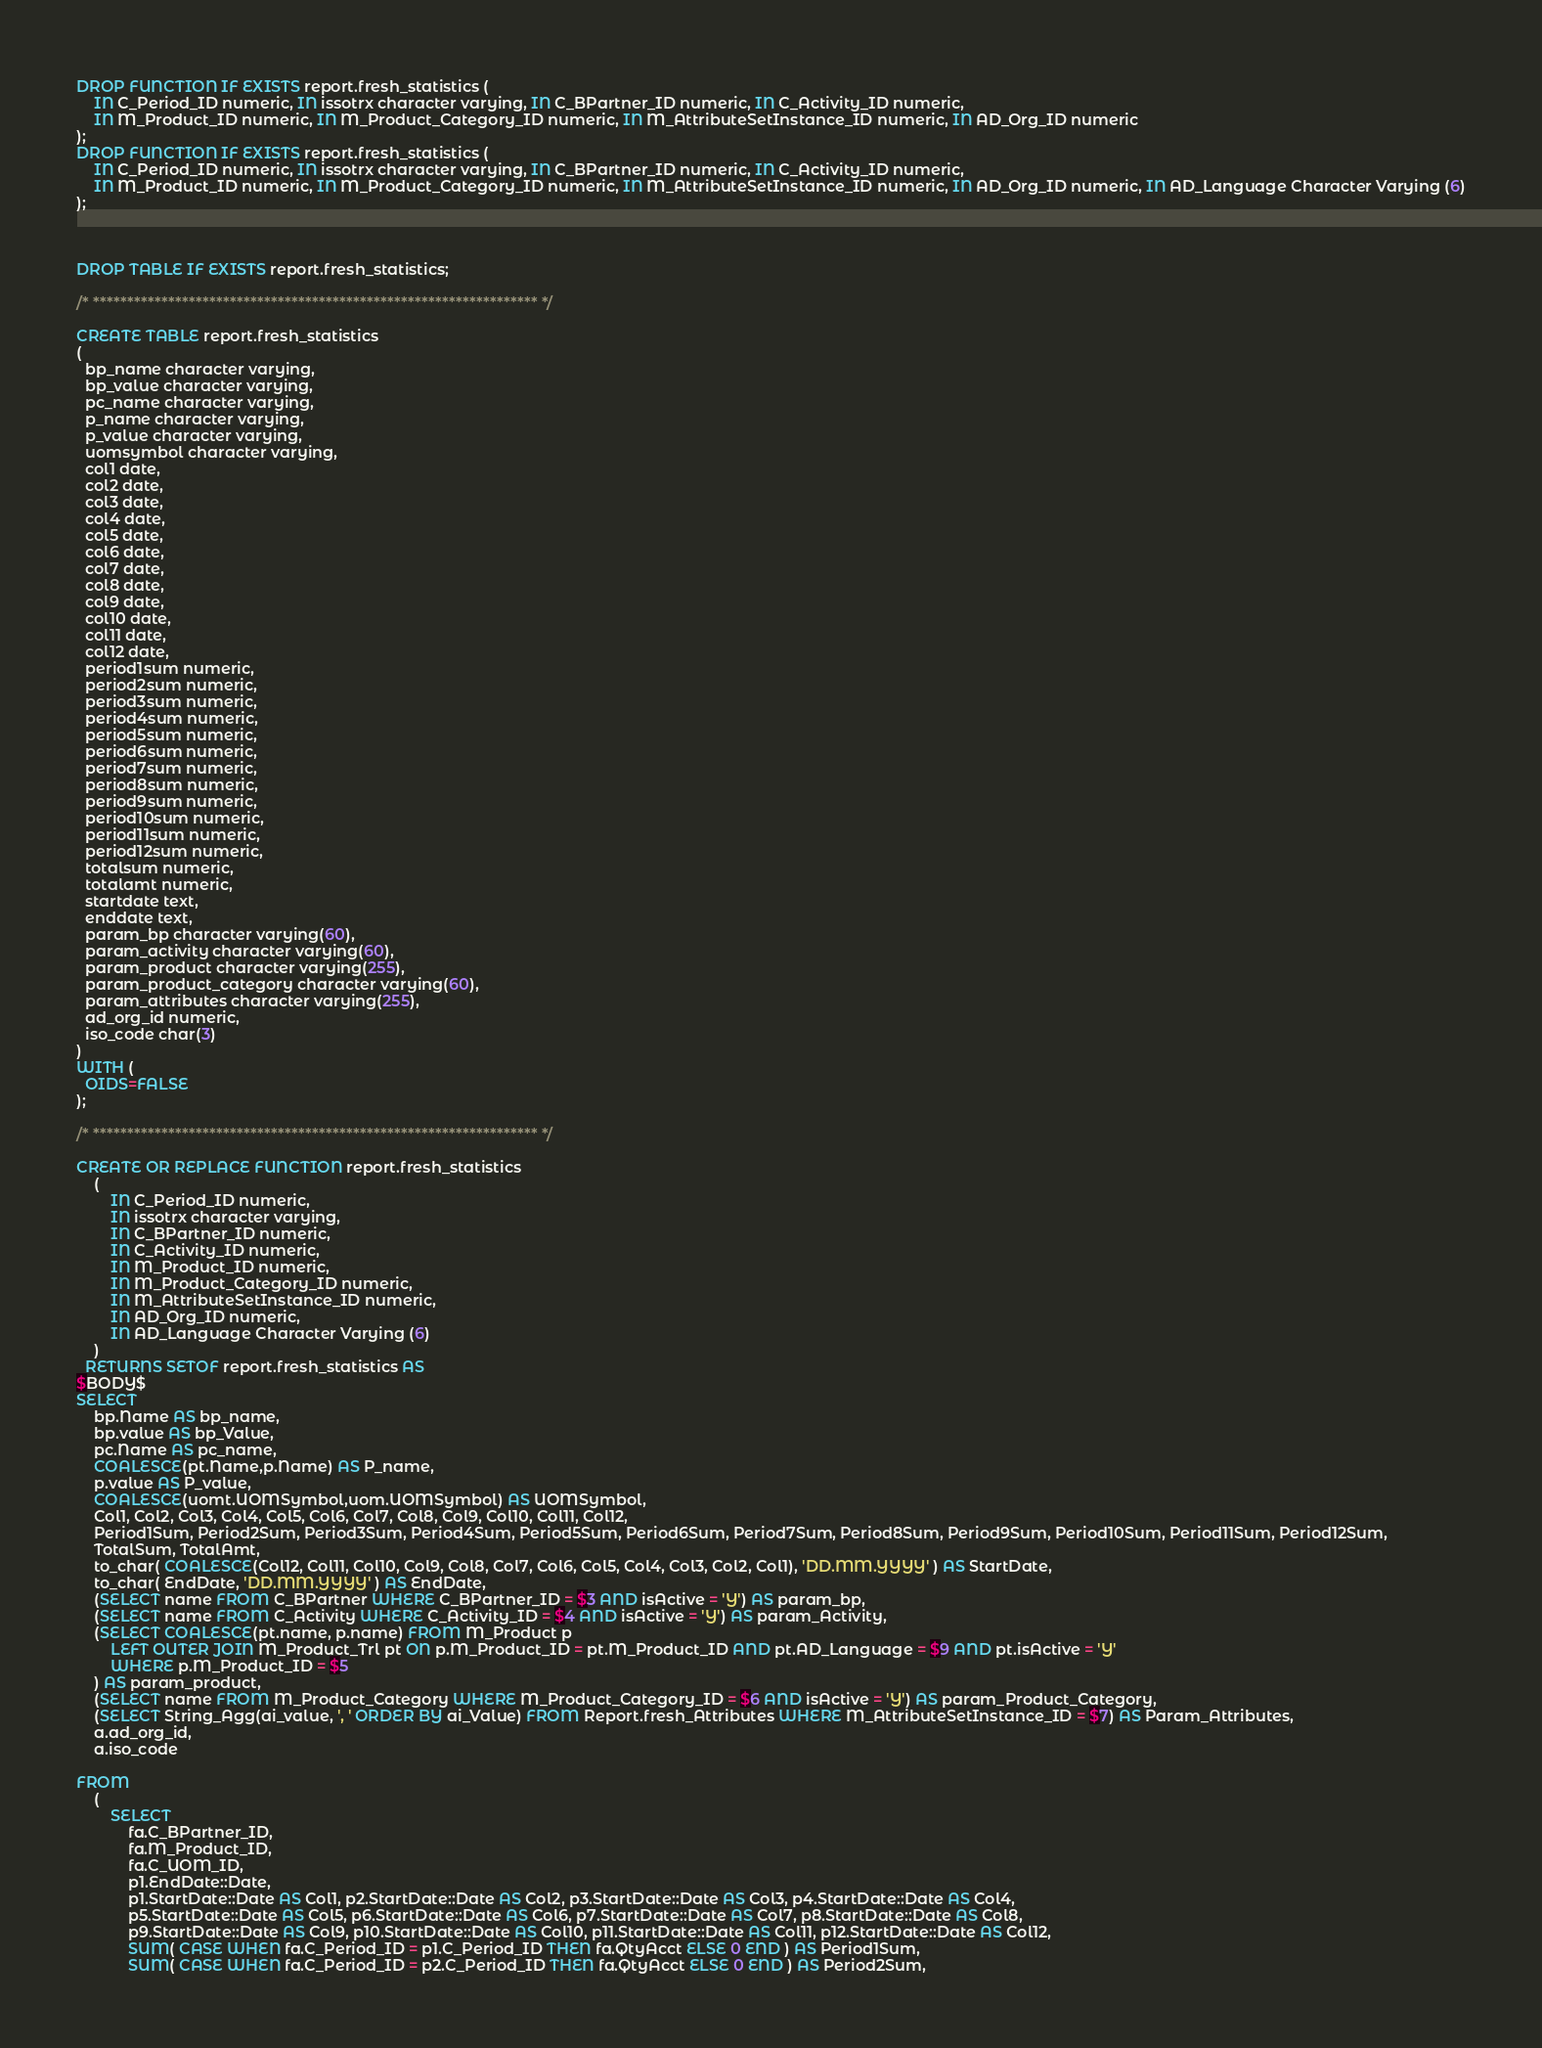Convert code to text. <code><loc_0><loc_0><loc_500><loc_500><_SQL_>DROP FUNCTION IF EXISTS report.fresh_statistics ( 
	IN C_Period_ID numeric, IN issotrx character varying, IN C_BPartner_ID numeric, IN C_Activity_ID numeric,
	IN M_Product_ID numeric, IN M_Product_Category_ID numeric, IN M_AttributeSetInstance_ID numeric, IN AD_Org_ID numeric
);
DROP FUNCTION IF EXISTS report.fresh_statistics ( 
	IN C_Period_ID numeric, IN issotrx character varying, IN C_BPartner_ID numeric, IN C_Activity_ID numeric,
	IN M_Product_ID numeric, IN M_Product_Category_ID numeric, IN M_AttributeSetInstance_ID numeric, IN AD_Org_ID numeric, IN AD_Language Character Varying (6)
);



DROP TABLE IF EXISTS report.fresh_statistics;

/* ***************************************************************** */

CREATE TABLE report.fresh_statistics
(
  bp_name character varying,
  bp_value character varying,
  pc_name character varying,
  p_name character varying,
  p_value character varying,
  uomsymbol character varying,
  col1 date,
  col2 date,
  col3 date,
  col4 date,
  col5 date,
  col6 date,
  col7 date,
  col8 date,
  col9 date,
  col10 date,
  col11 date,
  col12 date,
  period1sum numeric,
  period2sum numeric,
  period3sum numeric,
  period4sum numeric,
  period5sum numeric,
  period6sum numeric,
  period7sum numeric,
  period8sum numeric,
  period9sum numeric,
  period10sum numeric,
  period11sum numeric,
  period12sum numeric,
  totalsum numeric,
  totalamt numeric,
  startdate text,
  enddate text,
  param_bp character varying(60),
  param_activity character varying(60),
  param_product character varying(255),
  param_product_category character varying(60),
  param_attributes character varying(255),
  ad_org_id numeric,
  iso_code char(3)
)
WITH (
  OIDS=FALSE
);

/* ***************************************************************** */

CREATE OR REPLACE FUNCTION report.fresh_statistics
	(
		IN C_Period_ID numeric, 
		IN issotrx character varying,
		IN C_BPartner_ID numeric, 
		IN C_Activity_ID numeric,
		IN M_Product_ID numeric,
		IN M_Product_Category_ID numeric,
		IN M_AttributeSetInstance_ID numeric,
		IN AD_Org_ID numeric,
		IN AD_Language Character Varying (6) 
	) 
  RETURNS SETOF report.fresh_statistics AS
$BODY$
SELECT
	bp.Name AS bp_name,
	bp.value AS bp_Value,
	pc.Name AS pc_name, 
	COALESCE(pt.Name,p.Name) AS P_name,
	p.value AS P_value,
	COALESCE(uomt.UOMSymbol,uom.UOMSymbol) AS UOMSymbol,
	Col1, Col2, Col3, Col4, Col5, Col6, Col7, Col8, Col9, Col10, Col11, Col12,
	Period1Sum, Period2Sum, Period3Sum, Period4Sum, Period5Sum, Period6Sum, Period7Sum, Period8Sum, Period9Sum, Period10Sum, Period11Sum, Period12Sum,
	TotalSum, TotalAmt,
	to_char( COALESCE(Col12, Col11, Col10, Col9, Col8, Col7, Col6, Col5, Col4, Col3, Col2, Col1), 'DD.MM.YYYY' ) AS StartDate,
	to_char( EndDate, 'DD.MM.YYYY' ) AS EndDate,
	(SELECT name FROM C_BPartner WHERE C_BPartner_ID = $3 AND isActive = 'Y') AS param_bp,
	(SELECT name FROM C_Activity WHERE C_Activity_ID = $4 AND isActive = 'Y') AS param_Activity,
	(SELECT COALESCE(pt.name, p.name) FROM M_Product p 
		LEFT OUTER JOIN M_Product_Trl pt ON p.M_Product_ID = pt.M_Product_ID AND pt.AD_Language = $9 AND pt.isActive = 'Y'
		WHERE p.M_Product_ID = $5
	) AS param_product,
	(SELECT name FROM M_Product_Category WHERE M_Product_Category_ID = $6 AND isActive = 'Y') AS param_Product_Category,
	(SELECT String_Agg(ai_value, ', ' ORDER BY ai_Value) FROM Report.fresh_Attributes WHERE M_AttributeSetInstance_ID = $7) AS Param_Attributes,
	a.ad_org_id,
	a.iso_code

FROM
	(
		SELECT
			fa.C_BPartner_ID,
			fa.M_Product_ID,
			fa.C_UOM_ID, 
			p1.EndDate::Date,
			p1.StartDate::Date AS Col1, p2.StartDate::Date AS Col2, p3.StartDate::Date AS Col3, p4.StartDate::Date AS Col4, 
			p5.StartDate::Date AS Col5, p6.StartDate::Date AS Col6, p7.StartDate::Date AS Col7, p8.StartDate::Date AS Col8, 
			p9.StartDate::Date AS Col9, p10.StartDate::Date AS Col10, p11.StartDate::Date AS Col11, p12.StartDate::Date AS Col12,
			SUM( CASE WHEN fa.C_Period_ID = p1.C_Period_ID THEN fa.QtyAcct ELSE 0 END ) AS Period1Sum,
			SUM( CASE WHEN fa.C_Period_ID = p2.C_Period_ID THEN fa.QtyAcct ELSE 0 END ) AS Period2Sum,</code> 